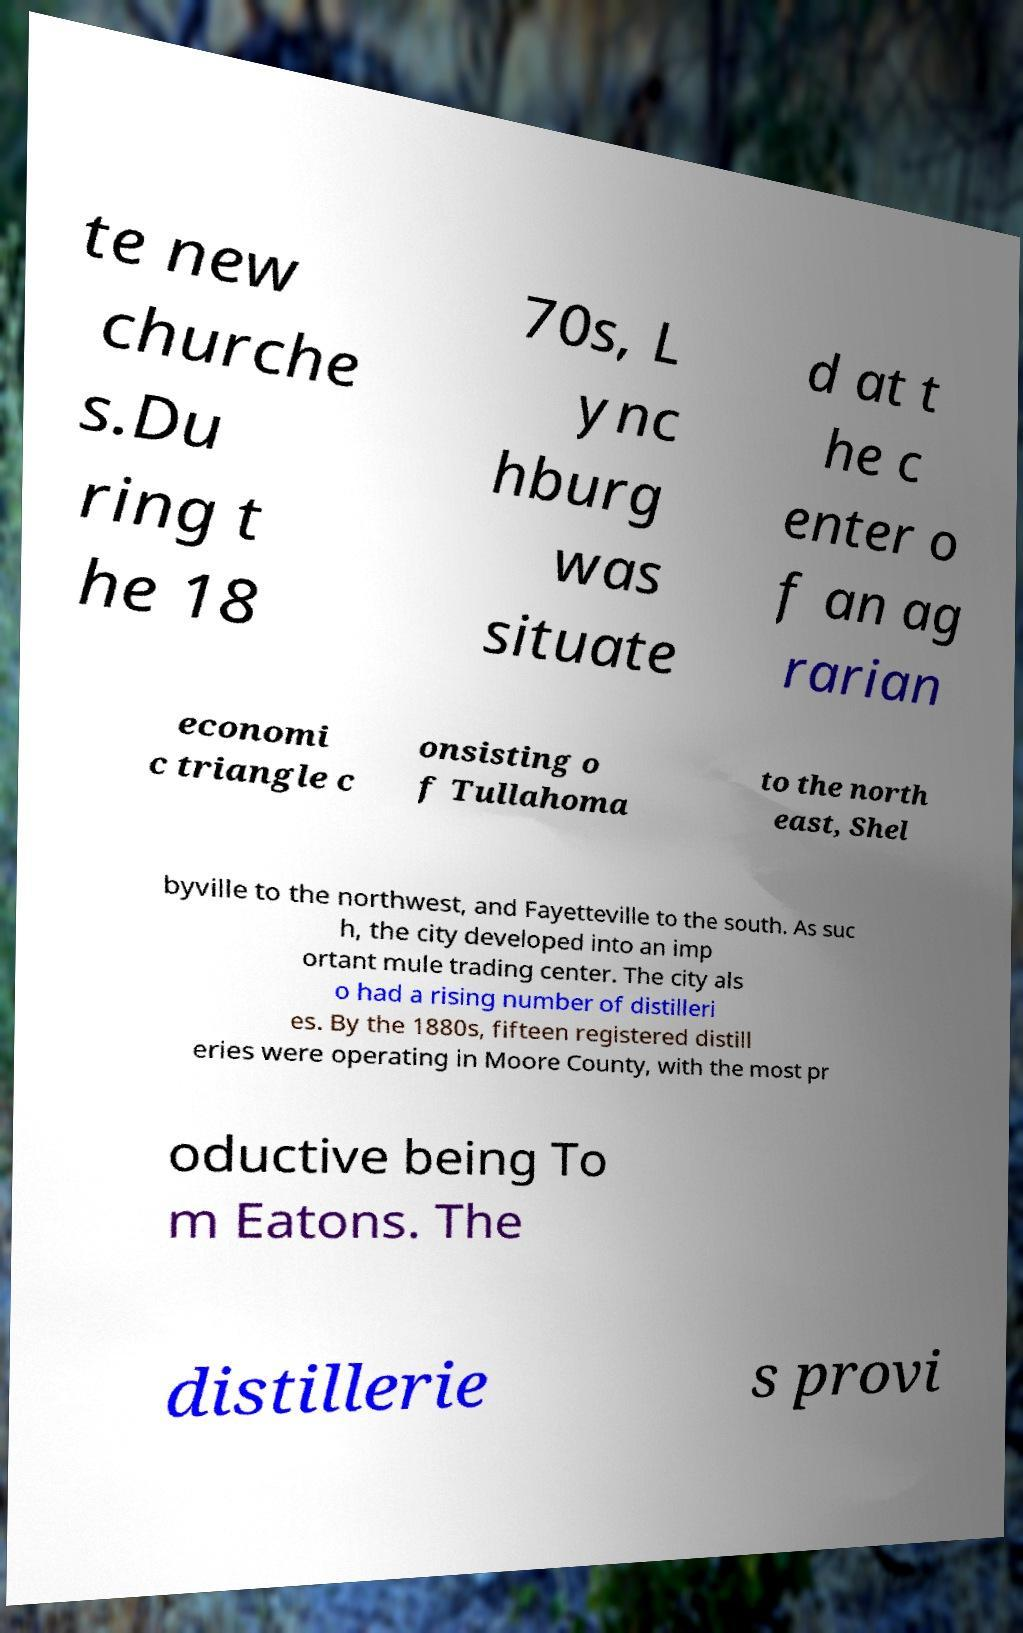Please read and relay the text visible in this image. What does it say? te new churche s.Du ring t he 18 70s, L ync hburg was situate d at t he c enter o f an ag rarian economi c triangle c onsisting o f Tullahoma to the north east, Shel byville to the northwest, and Fayetteville to the south. As suc h, the city developed into an imp ortant mule trading center. The city als o had a rising number of distilleri es. By the 1880s, fifteen registered distill eries were operating in Moore County, with the most pr oductive being To m Eatons. The distillerie s provi 